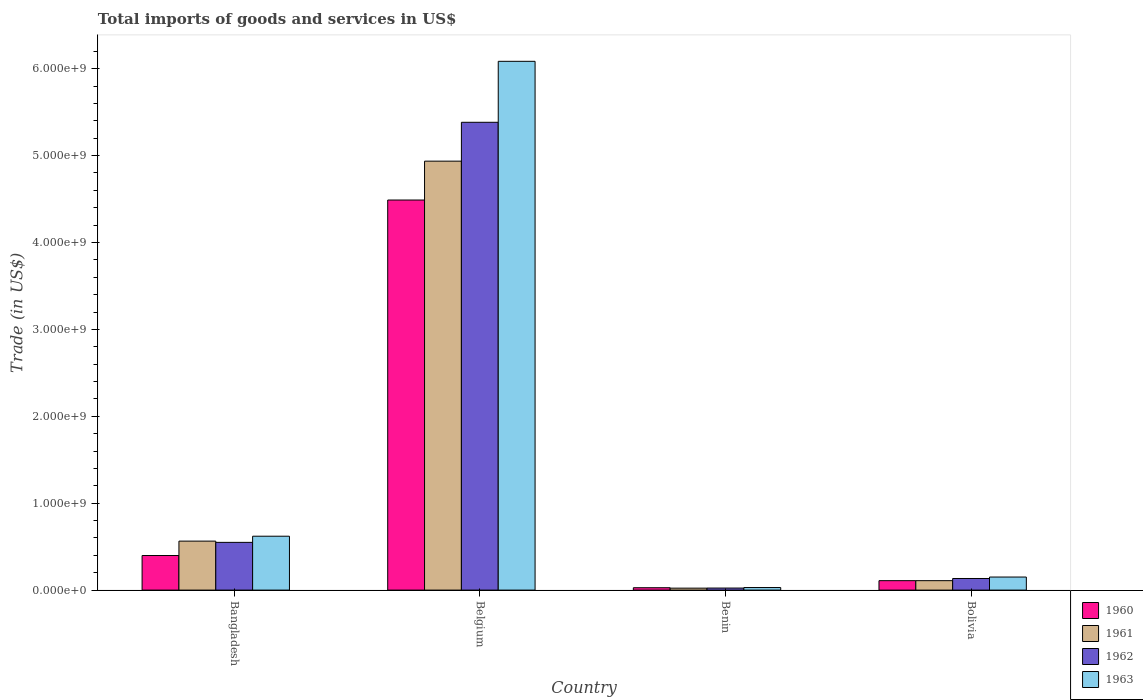How many different coloured bars are there?
Make the answer very short. 4. How many groups of bars are there?
Your answer should be very brief. 4. Are the number of bars per tick equal to the number of legend labels?
Offer a very short reply. Yes. Are the number of bars on each tick of the X-axis equal?
Your response must be concise. Yes. What is the label of the 4th group of bars from the left?
Your answer should be compact. Bolivia. What is the total imports of goods and services in 1962 in Benin?
Your answer should be very brief. 2.35e+07. Across all countries, what is the maximum total imports of goods and services in 1962?
Offer a terse response. 5.38e+09. Across all countries, what is the minimum total imports of goods and services in 1961?
Your answer should be compact. 2.25e+07. In which country was the total imports of goods and services in 1960 minimum?
Offer a terse response. Benin. What is the total total imports of goods and services in 1962 in the graph?
Make the answer very short. 6.09e+09. What is the difference between the total imports of goods and services in 1961 in Belgium and that in Benin?
Your response must be concise. 4.91e+09. What is the difference between the total imports of goods and services in 1960 in Benin and the total imports of goods and services in 1961 in Belgium?
Your answer should be compact. -4.91e+09. What is the average total imports of goods and services in 1960 per country?
Offer a terse response. 1.26e+09. What is the difference between the total imports of goods and services of/in 1961 and total imports of goods and services of/in 1962 in Bolivia?
Offer a terse response. -2.50e+07. In how many countries, is the total imports of goods and services in 1961 greater than 200000000 US$?
Your response must be concise. 2. What is the ratio of the total imports of goods and services in 1963 in Benin to that in Bolivia?
Offer a very short reply. 0.2. Is the difference between the total imports of goods and services in 1961 in Belgium and Bolivia greater than the difference between the total imports of goods and services in 1962 in Belgium and Bolivia?
Give a very brief answer. No. What is the difference between the highest and the second highest total imports of goods and services in 1962?
Provide a short and direct response. 4.83e+09. What is the difference between the highest and the lowest total imports of goods and services in 1961?
Make the answer very short. 4.91e+09. In how many countries, is the total imports of goods and services in 1963 greater than the average total imports of goods and services in 1963 taken over all countries?
Your answer should be very brief. 1. Is the sum of the total imports of goods and services in 1963 in Bangladesh and Benin greater than the maximum total imports of goods and services in 1962 across all countries?
Your answer should be compact. No. Is it the case that in every country, the sum of the total imports of goods and services in 1962 and total imports of goods and services in 1963 is greater than the sum of total imports of goods and services in 1960 and total imports of goods and services in 1961?
Your answer should be compact. No. What does the 2nd bar from the left in Bolivia represents?
Offer a very short reply. 1961. Is it the case that in every country, the sum of the total imports of goods and services in 1960 and total imports of goods and services in 1963 is greater than the total imports of goods and services in 1962?
Offer a terse response. Yes. How many countries are there in the graph?
Your answer should be very brief. 4. Does the graph contain any zero values?
Your response must be concise. No. Where does the legend appear in the graph?
Ensure brevity in your answer.  Bottom right. How many legend labels are there?
Give a very brief answer. 4. How are the legend labels stacked?
Offer a terse response. Vertical. What is the title of the graph?
Provide a succinct answer. Total imports of goods and services in US$. Does "1986" appear as one of the legend labels in the graph?
Offer a very short reply. No. What is the label or title of the X-axis?
Your answer should be compact. Country. What is the label or title of the Y-axis?
Ensure brevity in your answer.  Trade (in US$). What is the Trade (in US$) of 1960 in Bangladesh?
Provide a succinct answer. 3.98e+08. What is the Trade (in US$) in 1961 in Bangladesh?
Your response must be concise. 5.64e+08. What is the Trade (in US$) in 1962 in Bangladesh?
Your response must be concise. 5.49e+08. What is the Trade (in US$) in 1963 in Bangladesh?
Ensure brevity in your answer.  6.20e+08. What is the Trade (in US$) of 1960 in Belgium?
Make the answer very short. 4.49e+09. What is the Trade (in US$) of 1961 in Belgium?
Your answer should be compact. 4.94e+09. What is the Trade (in US$) in 1962 in Belgium?
Ensure brevity in your answer.  5.38e+09. What is the Trade (in US$) in 1963 in Belgium?
Ensure brevity in your answer.  6.08e+09. What is the Trade (in US$) in 1960 in Benin?
Give a very brief answer. 2.74e+07. What is the Trade (in US$) in 1961 in Benin?
Provide a succinct answer. 2.25e+07. What is the Trade (in US$) of 1962 in Benin?
Make the answer very short. 2.35e+07. What is the Trade (in US$) of 1963 in Benin?
Offer a very short reply. 2.95e+07. What is the Trade (in US$) in 1960 in Bolivia?
Offer a very short reply. 1.09e+08. What is the Trade (in US$) of 1961 in Bolivia?
Offer a terse response. 1.09e+08. What is the Trade (in US$) of 1962 in Bolivia?
Your answer should be compact. 1.34e+08. What is the Trade (in US$) of 1963 in Bolivia?
Your answer should be compact. 1.50e+08. Across all countries, what is the maximum Trade (in US$) in 1960?
Provide a succinct answer. 4.49e+09. Across all countries, what is the maximum Trade (in US$) of 1961?
Ensure brevity in your answer.  4.94e+09. Across all countries, what is the maximum Trade (in US$) of 1962?
Your response must be concise. 5.38e+09. Across all countries, what is the maximum Trade (in US$) in 1963?
Offer a very short reply. 6.08e+09. Across all countries, what is the minimum Trade (in US$) of 1960?
Your answer should be compact. 2.74e+07. Across all countries, what is the minimum Trade (in US$) in 1961?
Keep it short and to the point. 2.25e+07. Across all countries, what is the minimum Trade (in US$) in 1962?
Ensure brevity in your answer.  2.35e+07. Across all countries, what is the minimum Trade (in US$) of 1963?
Offer a terse response. 2.95e+07. What is the total Trade (in US$) in 1960 in the graph?
Provide a short and direct response. 5.02e+09. What is the total Trade (in US$) in 1961 in the graph?
Your answer should be compact. 5.63e+09. What is the total Trade (in US$) in 1962 in the graph?
Ensure brevity in your answer.  6.09e+09. What is the total Trade (in US$) of 1963 in the graph?
Provide a succinct answer. 6.88e+09. What is the difference between the Trade (in US$) of 1960 in Bangladesh and that in Belgium?
Your answer should be very brief. -4.09e+09. What is the difference between the Trade (in US$) in 1961 in Bangladesh and that in Belgium?
Offer a very short reply. -4.37e+09. What is the difference between the Trade (in US$) in 1962 in Bangladesh and that in Belgium?
Provide a succinct answer. -4.83e+09. What is the difference between the Trade (in US$) of 1963 in Bangladesh and that in Belgium?
Ensure brevity in your answer.  -5.46e+09. What is the difference between the Trade (in US$) of 1960 in Bangladesh and that in Benin?
Provide a short and direct response. 3.70e+08. What is the difference between the Trade (in US$) in 1961 in Bangladesh and that in Benin?
Ensure brevity in your answer.  5.41e+08. What is the difference between the Trade (in US$) of 1962 in Bangladesh and that in Benin?
Provide a succinct answer. 5.26e+08. What is the difference between the Trade (in US$) of 1963 in Bangladesh and that in Benin?
Make the answer very short. 5.91e+08. What is the difference between the Trade (in US$) in 1960 in Bangladesh and that in Bolivia?
Give a very brief answer. 2.89e+08. What is the difference between the Trade (in US$) in 1961 in Bangladesh and that in Bolivia?
Your answer should be compact. 4.55e+08. What is the difference between the Trade (in US$) of 1962 in Bangladesh and that in Bolivia?
Your answer should be compact. 4.16e+08. What is the difference between the Trade (in US$) in 1963 in Bangladesh and that in Bolivia?
Make the answer very short. 4.70e+08. What is the difference between the Trade (in US$) in 1960 in Belgium and that in Benin?
Provide a short and direct response. 4.46e+09. What is the difference between the Trade (in US$) of 1961 in Belgium and that in Benin?
Offer a terse response. 4.91e+09. What is the difference between the Trade (in US$) of 1962 in Belgium and that in Benin?
Offer a very short reply. 5.36e+09. What is the difference between the Trade (in US$) of 1963 in Belgium and that in Benin?
Offer a terse response. 6.06e+09. What is the difference between the Trade (in US$) in 1960 in Belgium and that in Bolivia?
Offer a terse response. 4.38e+09. What is the difference between the Trade (in US$) of 1961 in Belgium and that in Bolivia?
Make the answer very short. 4.83e+09. What is the difference between the Trade (in US$) of 1962 in Belgium and that in Bolivia?
Ensure brevity in your answer.  5.25e+09. What is the difference between the Trade (in US$) in 1963 in Belgium and that in Bolivia?
Provide a short and direct response. 5.93e+09. What is the difference between the Trade (in US$) of 1960 in Benin and that in Bolivia?
Make the answer very short. -8.11e+07. What is the difference between the Trade (in US$) in 1961 in Benin and that in Bolivia?
Keep it short and to the point. -8.60e+07. What is the difference between the Trade (in US$) of 1962 in Benin and that in Bolivia?
Keep it short and to the point. -1.10e+08. What is the difference between the Trade (in US$) in 1963 in Benin and that in Bolivia?
Your answer should be very brief. -1.21e+08. What is the difference between the Trade (in US$) in 1960 in Bangladesh and the Trade (in US$) in 1961 in Belgium?
Provide a succinct answer. -4.54e+09. What is the difference between the Trade (in US$) in 1960 in Bangladesh and the Trade (in US$) in 1962 in Belgium?
Ensure brevity in your answer.  -4.99e+09. What is the difference between the Trade (in US$) of 1960 in Bangladesh and the Trade (in US$) of 1963 in Belgium?
Give a very brief answer. -5.69e+09. What is the difference between the Trade (in US$) of 1961 in Bangladesh and the Trade (in US$) of 1962 in Belgium?
Offer a terse response. -4.82e+09. What is the difference between the Trade (in US$) in 1961 in Bangladesh and the Trade (in US$) in 1963 in Belgium?
Offer a terse response. -5.52e+09. What is the difference between the Trade (in US$) of 1962 in Bangladesh and the Trade (in US$) of 1963 in Belgium?
Keep it short and to the point. -5.54e+09. What is the difference between the Trade (in US$) in 1960 in Bangladesh and the Trade (in US$) in 1961 in Benin?
Provide a succinct answer. 3.75e+08. What is the difference between the Trade (in US$) in 1960 in Bangladesh and the Trade (in US$) in 1962 in Benin?
Provide a short and direct response. 3.74e+08. What is the difference between the Trade (in US$) in 1960 in Bangladesh and the Trade (in US$) in 1963 in Benin?
Your response must be concise. 3.68e+08. What is the difference between the Trade (in US$) of 1961 in Bangladesh and the Trade (in US$) of 1962 in Benin?
Make the answer very short. 5.40e+08. What is the difference between the Trade (in US$) of 1961 in Bangladesh and the Trade (in US$) of 1963 in Benin?
Make the answer very short. 5.34e+08. What is the difference between the Trade (in US$) of 1962 in Bangladesh and the Trade (in US$) of 1963 in Benin?
Offer a terse response. 5.20e+08. What is the difference between the Trade (in US$) of 1960 in Bangladesh and the Trade (in US$) of 1961 in Bolivia?
Make the answer very short. 2.89e+08. What is the difference between the Trade (in US$) in 1960 in Bangladesh and the Trade (in US$) in 1962 in Bolivia?
Offer a very short reply. 2.64e+08. What is the difference between the Trade (in US$) in 1960 in Bangladesh and the Trade (in US$) in 1963 in Bolivia?
Your response must be concise. 2.48e+08. What is the difference between the Trade (in US$) in 1961 in Bangladesh and the Trade (in US$) in 1962 in Bolivia?
Your response must be concise. 4.30e+08. What is the difference between the Trade (in US$) of 1961 in Bangladesh and the Trade (in US$) of 1963 in Bolivia?
Offer a very short reply. 4.13e+08. What is the difference between the Trade (in US$) of 1962 in Bangladesh and the Trade (in US$) of 1963 in Bolivia?
Your answer should be very brief. 3.99e+08. What is the difference between the Trade (in US$) in 1960 in Belgium and the Trade (in US$) in 1961 in Benin?
Keep it short and to the point. 4.47e+09. What is the difference between the Trade (in US$) in 1960 in Belgium and the Trade (in US$) in 1962 in Benin?
Keep it short and to the point. 4.47e+09. What is the difference between the Trade (in US$) in 1960 in Belgium and the Trade (in US$) in 1963 in Benin?
Provide a succinct answer. 4.46e+09. What is the difference between the Trade (in US$) in 1961 in Belgium and the Trade (in US$) in 1962 in Benin?
Provide a succinct answer. 4.91e+09. What is the difference between the Trade (in US$) of 1961 in Belgium and the Trade (in US$) of 1963 in Benin?
Give a very brief answer. 4.91e+09. What is the difference between the Trade (in US$) in 1962 in Belgium and the Trade (in US$) in 1963 in Benin?
Offer a very short reply. 5.35e+09. What is the difference between the Trade (in US$) in 1960 in Belgium and the Trade (in US$) in 1961 in Bolivia?
Give a very brief answer. 4.38e+09. What is the difference between the Trade (in US$) in 1960 in Belgium and the Trade (in US$) in 1962 in Bolivia?
Keep it short and to the point. 4.36e+09. What is the difference between the Trade (in US$) of 1960 in Belgium and the Trade (in US$) of 1963 in Bolivia?
Offer a terse response. 4.34e+09. What is the difference between the Trade (in US$) of 1961 in Belgium and the Trade (in US$) of 1962 in Bolivia?
Give a very brief answer. 4.80e+09. What is the difference between the Trade (in US$) in 1961 in Belgium and the Trade (in US$) in 1963 in Bolivia?
Offer a terse response. 4.79e+09. What is the difference between the Trade (in US$) in 1962 in Belgium and the Trade (in US$) in 1963 in Bolivia?
Provide a succinct answer. 5.23e+09. What is the difference between the Trade (in US$) in 1960 in Benin and the Trade (in US$) in 1961 in Bolivia?
Provide a succinct answer. -8.11e+07. What is the difference between the Trade (in US$) in 1960 in Benin and the Trade (in US$) in 1962 in Bolivia?
Make the answer very short. -1.06e+08. What is the difference between the Trade (in US$) in 1960 in Benin and the Trade (in US$) in 1963 in Bolivia?
Your answer should be compact. -1.23e+08. What is the difference between the Trade (in US$) in 1961 in Benin and the Trade (in US$) in 1962 in Bolivia?
Offer a terse response. -1.11e+08. What is the difference between the Trade (in US$) of 1961 in Benin and the Trade (in US$) of 1963 in Bolivia?
Your response must be concise. -1.28e+08. What is the difference between the Trade (in US$) in 1962 in Benin and the Trade (in US$) in 1963 in Bolivia?
Offer a very short reply. -1.27e+08. What is the average Trade (in US$) of 1960 per country?
Your response must be concise. 1.26e+09. What is the average Trade (in US$) in 1961 per country?
Make the answer very short. 1.41e+09. What is the average Trade (in US$) in 1962 per country?
Offer a terse response. 1.52e+09. What is the average Trade (in US$) in 1963 per country?
Ensure brevity in your answer.  1.72e+09. What is the difference between the Trade (in US$) of 1960 and Trade (in US$) of 1961 in Bangladesh?
Ensure brevity in your answer.  -1.66e+08. What is the difference between the Trade (in US$) in 1960 and Trade (in US$) in 1962 in Bangladesh?
Provide a short and direct response. -1.51e+08. What is the difference between the Trade (in US$) of 1960 and Trade (in US$) of 1963 in Bangladesh?
Offer a terse response. -2.22e+08. What is the difference between the Trade (in US$) in 1961 and Trade (in US$) in 1962 in Bangladesh?
Provide a succinct answer. 1.45e+07. What is the difference between the Trade (in US$) in 1961 and Trade (in US$) in 1963 in Bangladesh?
Offer a very short reply. -5.64e+07. What is the difference between the Trade (in US$) of 1962 and Trade (in US$) of 1963 in Bangladesh?
Your answer should be compact. -7.08e+07. What is the difference between the Trade (in US$) in 1960 and Trade (in US$) in 1961 in Belgium?
Your answer should be very brief. -4.47e+08. What is the difference between the Trade (in US$) in 1960 and Trade (in US$) in 1962 in Belgium?
Provide a short and direct response. -8.94e+08. What is the difference between the Trade (in US$) of 1960 and Trade (in US$) of 1963 in Belgium?
Keep it short and to the point. -1.60e+09. What is the difference between the Trade (in US$) in 1961 and Trade (in US$) in 1962 in Belgium?
Provide a short and direct response. -4.47e+08. What is the difference between the Trade (in US$) in 1961 and Trade (in US$) in 1963 in Belgium?
Your response must be concise. -1.15e+09. What is the difference between the Trade (in US$) of 1962 and Trade (in US$) of 1963 in Belgium?
Provide a short and direct response. -7.02e+08. What is the difference between the Trade (in US$) of 1960 and Trade (in US$) of 1961 in Benin?
Offer a terse response. 4.92e+06. What is the difference between the Trade (in US$) of 1960 and Trade (in US$) of 1962 in Benin?
Offer a terse response. 3.85e+06. What is the difference between the Trade (in US$) in 1960 and Trade (in US$) in 1963 in Benin?
Offer a very short reply. -2.13e+06. What is the difference between the Trade (in US$) in 1961 and Trade (in US$) in 1962 in Benin?
Provide a succinct answer. -1.08e+06. What is the difference between the Trade (in US$) of 1961 and Trade (in US$) of 1963 in Benin?
Provide a short and direct response. -7.05e+06. What is the difference between the Trade (in US$) in 1962 and Trade (in US$) in 1963 in Benin?
Your response must be concise. -5.97e+06. What is the difference between the Trade (in US$) in 1960 and Trade (in US$) in 1962 in Bolivia?
Your answer should be very brief. -2.50e+07. What is the difference between the Trade (in US$) of 1960 and Trade (in US$) of 1963 in Bolivia?
Your answer should be very brief. -4.17e+07. What is the difference between the Trade (in US$) in 1961 and Trade (in US$) in 1962 in Bolivia?
Offer a terse response. -2.50e+07. What is the difference between the Trade (in US$) in 1961 and Trade (in US$) in 1963 in Bolivia?
Offer a terse response. -4.17e+07. What is the difference between the Trade (in US$) in 1962 and Trade (in US$) in 1963 in Bolivia?
Give a very brief answer. -1.67e+07. What is the ratio of the Trade (in US$) of 1960 in Bangladesh to that in Belgium?
Your answer should be very brief. 0.09. What is the ratio of the Trade (in US$) in 1961 in Bangladesh to that in Belgium?
Make the answer very short. 0.11. What is the ratio of the Trade (in US$) in 1962 in Bangladesh to that in Belgium?
Provide a short and direct response. 0.1. What is the ratio of the Trade (in US$) in 1963 in Bangladesh to that in Belgium?
Your answer should be compact. 0.1. What is the ratio of the Trade (in US$) in 1960 in Bangladesh to that in Benin?
Your answer should be very brief. 14.52. What is the ratio of the Trade (in US$) in 1961 in Bangladesh to that in Benin?
Offer a very short reply. 25.08. What is the ratio of the Trade (in US$) of 1962 in Bangladesh to that in Benin?
Ensure brevity in your answer.  23.32. What is the ratio of the Trade (in US$) of 1963 in Bangladesh to that in Benin?
Provide a succinct answer. 21. What is the ratio of the Trade (in US$) of 1960 in Bangladesh to that in Bolivia?
Provide a succinct answer. 3.67. What is the ratio of the Trade (in US$) of 1961 in Bangladesh to that in Bolivia?
Offer a terse response. 5.19. What is the ratio of the Trade (in US$) in 1962 in Bangladesh to that in Bolivia?
Make the answer very short. 4.11. What is the ratio of the Trade (in US$) of 1963 in Bangladesh to that in Bolivia?
Provide a short and direct response. 4.13. What is the ratio of the Trade (in US$) of 1960 in Belgium to that in Benin?
Your answer should be very brief. 163.86. What is the ratio of the Trade (in US$) of 1961 in Belgium to that in Benin?
Your response must be concise. 219.67. What is the ratio of the Trade (in US$) in 1962 in Belgium to that in Benin?
Give a very brief answer. 228.61. What is the ratio of the Trade (in US$) in 1963 in Belgium to that in Benin?
Provide a short and direct response. 206.11. What is the ratio of the Trade (in US$) in 1960 in Belgium to that in Bolivia?
Keep it short and to the point. 41.36. What is the ratio of the Trade (in US$) in 1961 in Belgium to that in Bolivia?
Offer a very short reply. 45.49. What is the ratio of the Trade (in US$) in 1962 in Belgium to that in Bolivia?
Make the answer very short. 40.31. What is the ratio of the Trade (in US$) of 1963 in Belgium to that in Bolivia?
Ensure brevity in your answer.  40.5. What is the ratio of the Trade (in US$) in 1960 in Benin to that in Bolivia?
Offer a very short reply. 0.25. What is the ratio of the Trade (in US$) of 1961 in Benin to that in Bolivia?
Offer a very short reply. 0.21. What is the ratio of the Trade (in US$) of 1962 in Benin to that in Bolivia?
Give a very brief answer. 0.18. What is the ratio of the Trade (in US$) in 1963 in Benin to that in Bolivia?
Provide a succinct answer. 0.2. What is the difference between the highest and the second highest Trade (in US$) of 1960?
Offer a terse response. 4.09e+09. What is the difference between the highest and the second highest Trade (in US$) in 1961?
Make the answer very short. 4.37e+09. What is the difference between the highest and the second highest Trade (in US$) in 1962?
Make the answer very short. 4.83e+09. What is the difference between the highest and the second highest Trade (in US$) of 1963?
Offer a terse response. 5.46e+09. What is the difference between the highest and the lowest Trade (in US$) in 1960?
Provide a short and direct response. 4.46e+09. What is the difference between the highest and the lowest Trade (in US$) of 1961?
Ensure brevity in your answer.  4.91e+09. What is the difference between the highest and the lowest Trade (in US$) of 1962?
Provide a short and direct response. 5.36e+09. What is the difference between the highest and the lowest Trade (in US$) of 1963?
Make the answer very short. 6.06e+09. 